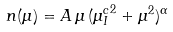<formula> <loc_0><loc_0><loc_500><loc_500>n ( \mu ) = A \, \mu \, ( { \mu _ { I } ^ { c } } ^ { 2 } + \mu ^ { 2 } ) ^ { \alpha }</formula> 